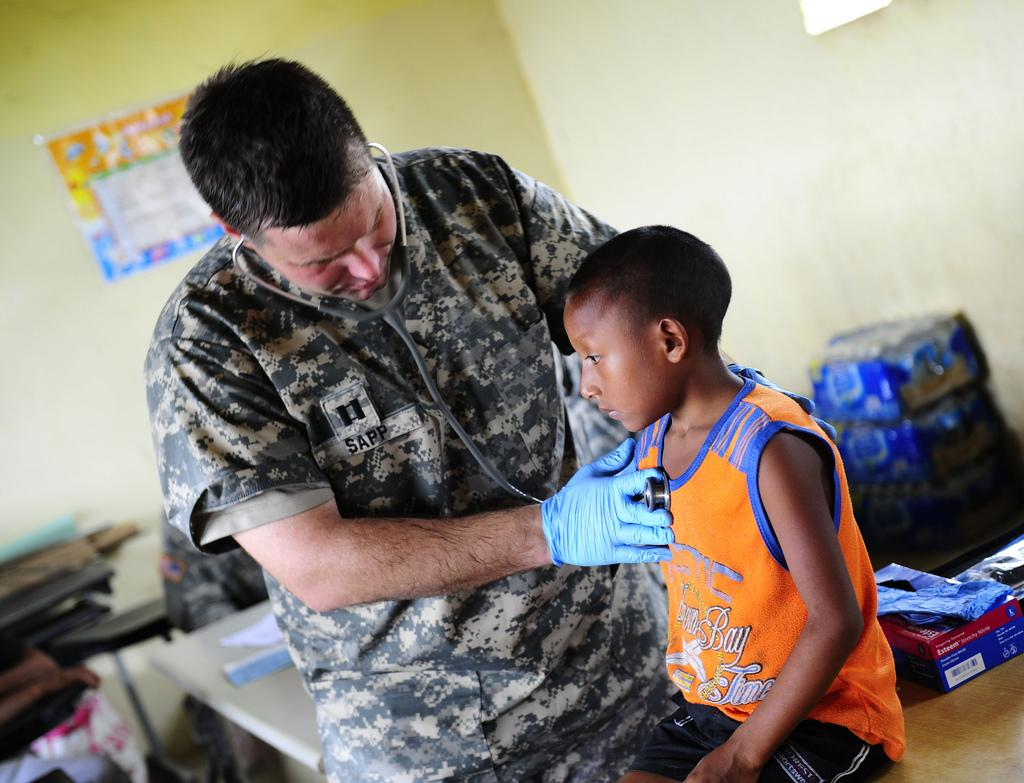How many people are in the image? There are two people in the image. What medical instrument can be seen in the image? A stethoscope is present in the image. What type of furniture is visible in the image? There are tables in the image. What is the small container in the image used for? There is a box in the image, which might be used for storing or organizing items. What type of items are present in the image? There are packets in the image, which might contain various materials or products. What else can be seen in the image? There are some unspecified objects in the image. What is on the wall in the background of the image? There is a poster on the wall in the background of the image. Can you tell me how many blades are on the shop in the image? There is no shop present in the image, and therefore no blades can be found. How does the person in the image stretch their arms? The image does not show any actions or movements of the people, so it is impossible to determine if they are stretching their arms. 